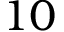Convert formula to latex. <formula><loc_0><loc_0><loc_500><loc_500>1 0</formula> 